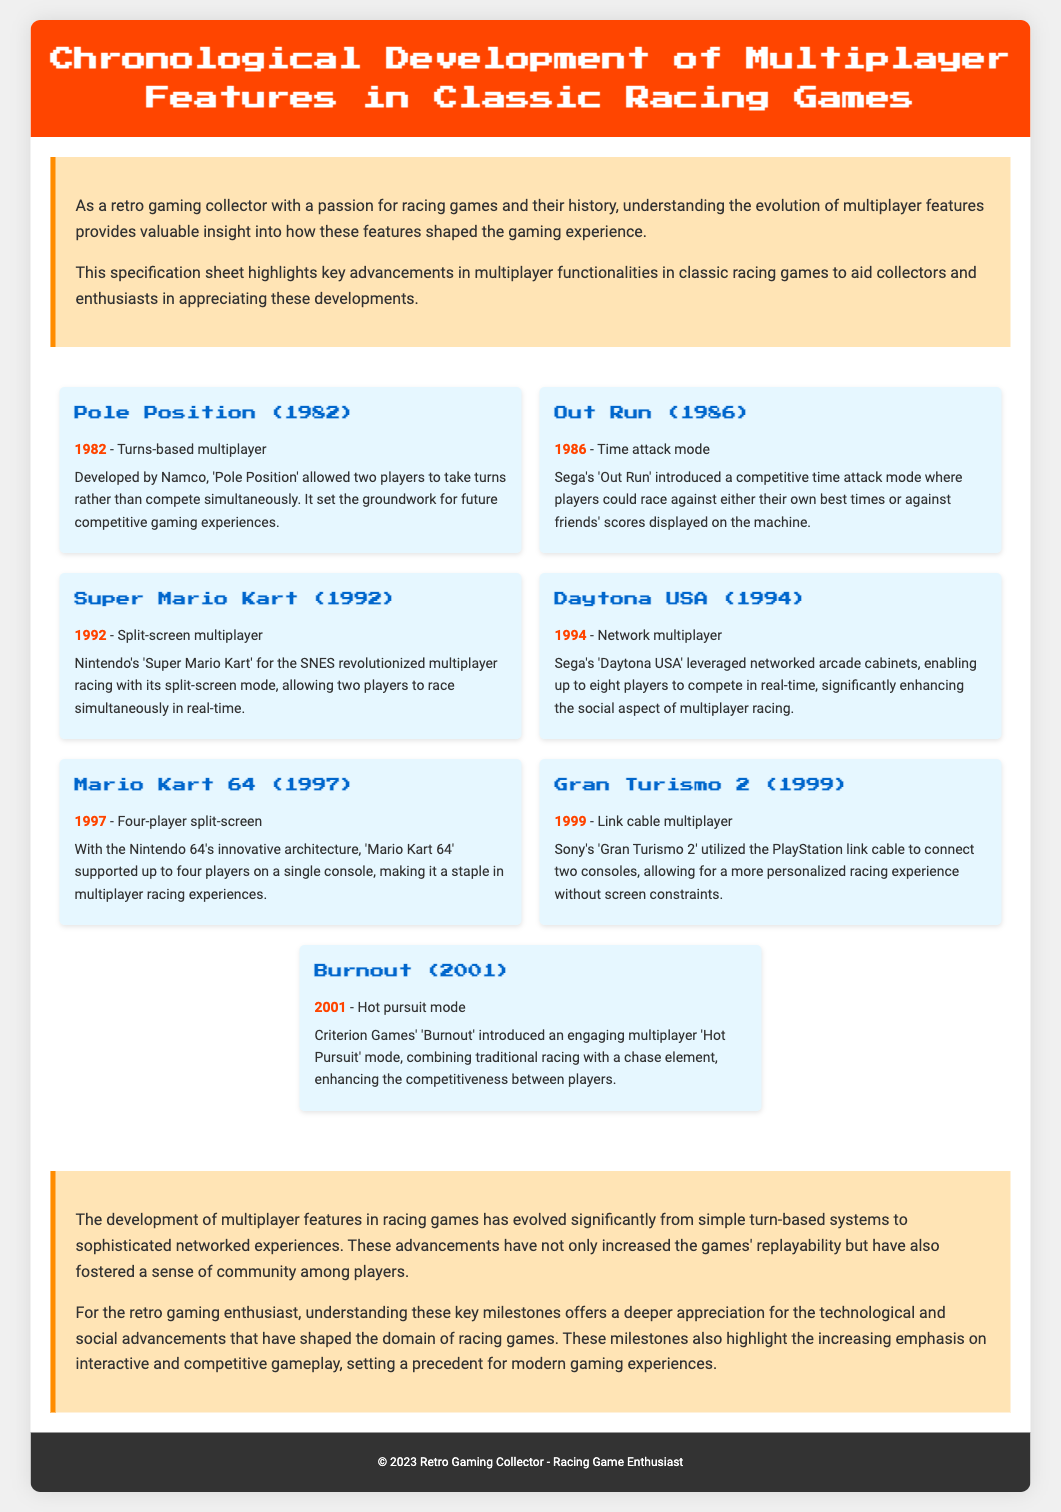What year was "Pole Position" released? The document states that "Pole Position" was released in 1982.
Answer: 1982 What multiplayer feature was introduced in "Out Run"? According to the document, "Out Run" introduced a time attack mode for multiplayer.
Answer: Time attack mode How many players could compete simultaneously in "Daytona USA"? The document mentions that "Daytona USA" enabled up to eight players to compete in real-time.
Answer: Eight players What is the unique multiplayer feature of "Gran Turismo 2"? The document highlights that "Gran Turismo 2" utilized a link cable multiplayer feature.
Answer: Link cable multiplayer Which game is noted for revolutionizing multiplayer racing with split-screen mode? The document states that "Super Mario Kart" revolutionized multiplayer racing with its split-screen mode.
Answer: Super Mario Kart Which game introduced the 'Hot Pursuit' mode? According to the document, "Burnout" introduced the engaging 'Hot Pursuit' mode.
Answer: Burnout What has significantly evolved in racing games according to the summary? The summary indicates that multiplayer features have significantly evolved from simple turn-based systems to sophisticated networked experiences.
Answer: Multiplayer features What was the primary emphasis introduced with the advancements in multiplayer functionalities? The document suggests that the advancements emphasized interactive and competitive gameplay.
Answer: Interactive and competitive gameplay 